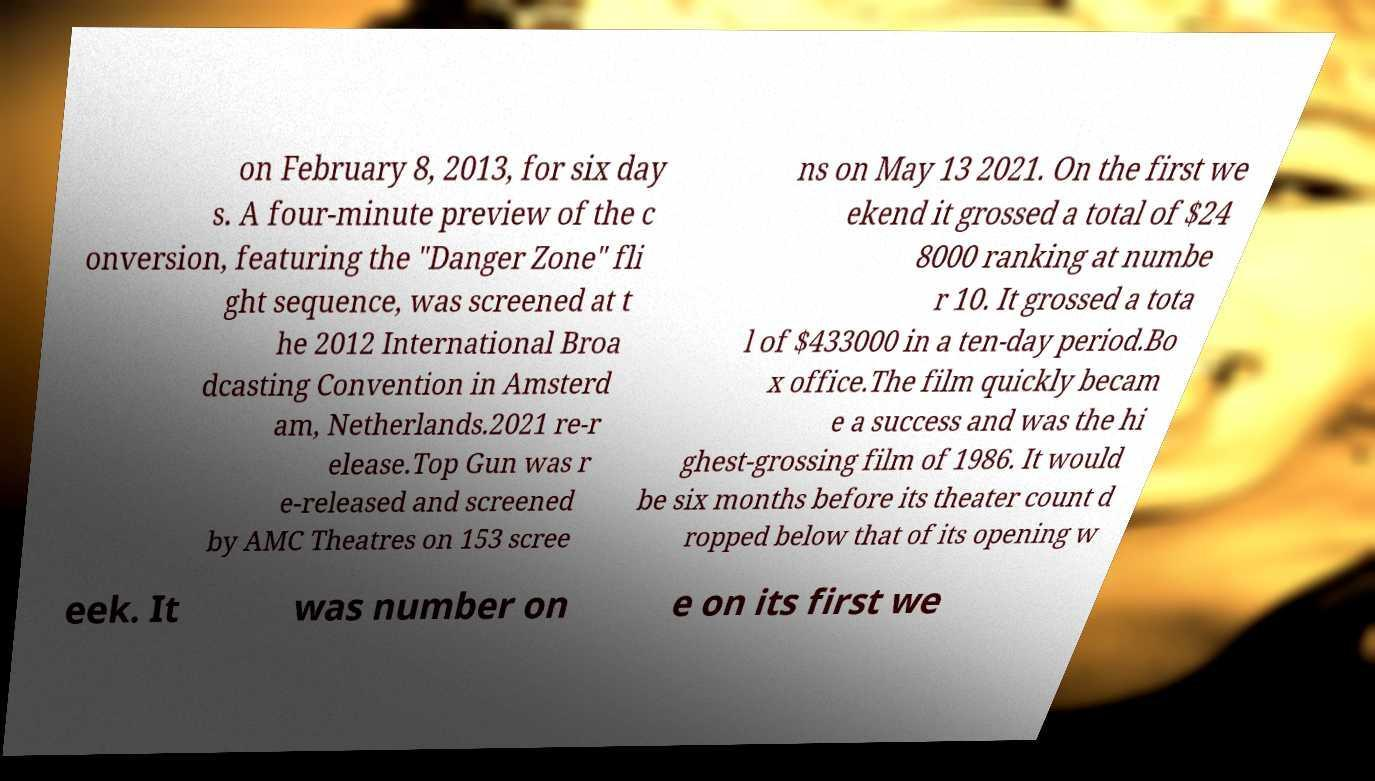Could you assist in decoding the text presented in this image and type it out clearly? on February 8, 2013, for six day s. A four-minute preview of the c onversion, featuring the "Danger Zone" fli ght sequence, was screened at t he 2012 International Broa dcasting Convention in Amsterd am, Netherlands.2021 re-r elease.Top Gun was r e-released and screened by AMC Theatres on 153 scree ns on May 13 2021. On the first we ekend it grossed a total of $24 8000 ranking at numbe r 10. It grossed a tota l of $433000 in a ten-day period.Bo x office.The film quickly becam e a success and was the hi ghest-grossing film of 1986. It would be six months before its theater count d ropped below that of its opening w eek. It was number on e on its first we 